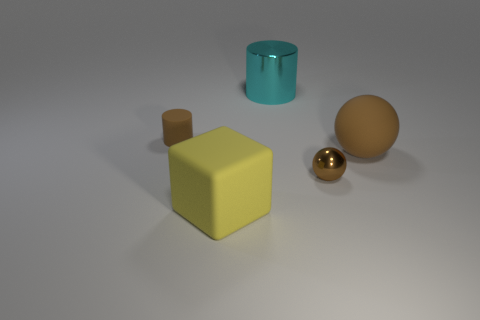Is the number of yellow things greater than the number of small blue matte cylinders?
Your response must be concise. Yes. What size is the metal ball that is the same color as the small cylinder?
Offer a terse response. Small. There is a large rubber thing on the left side of the big object that is behind the tiny matte cylinder; what is its shape?
Give a very brief answer. Cube. There is a brown rubber thing to the left of the cylinder that is to the right of the matte cylinder; is there a small brown sphere behind it?
Your response must be concise. No. The rubber thing that is the same size as the yellow matte block is what color?
Keep it short and to the point. Brown. There is a brown thing that is right of the rubber block and behind the metal ball; what shape is it?
Make the answer very short. Sphere. What is the size of the matte object in front of the brown matte thing right of the large yellow matte block?
Your response must be concise. Large. What number of tiny metallic spheres are the same color as the matte ball?
Your answer should be compact. 1. What number of other objects are the same size as the brown shiny thing?
Provide a succinct answer. 1. There is a object that is both in front of the big brown matte sphere and behind the matte cube; how big is it?
Offer a very short reply. Small. 